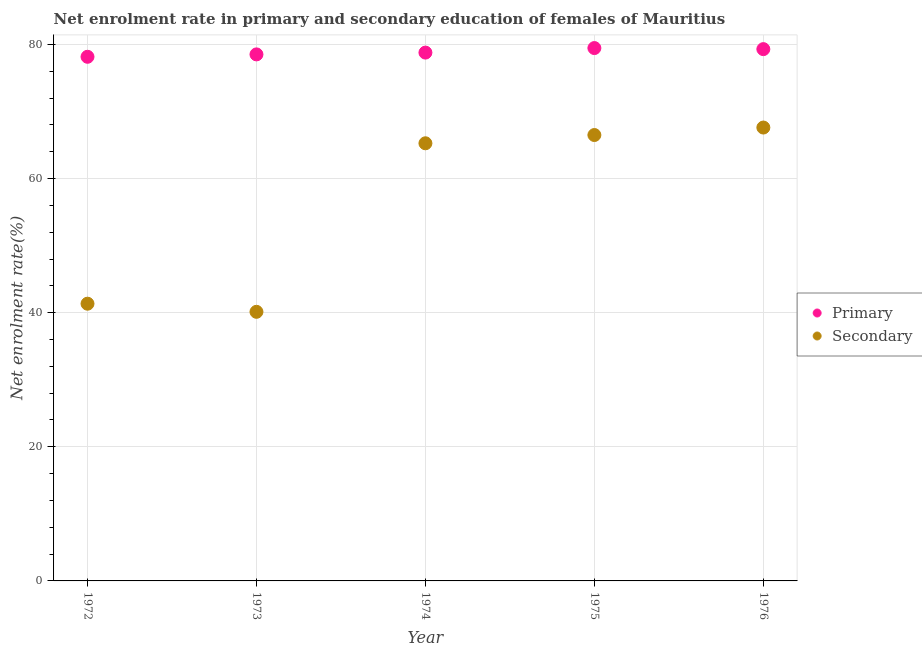How many different coloured dotlines are there?
Your response must be concise. 2. Is the number of dotlines equal to the number of legend labels?
Your answer should be very brief. Yes. What is the enrollment rate in primary education in 1974?
Your answer should be very brief. 78.79. Across all years, what is the maximum enrollment rate in secondary education?
Provide a short and direct response. 67.61. Across all years, what is the minimum enrollment rate in primary education?
Give a very brief answer. 78.16. In which year was the enrollment rate in primary education maximum?
Keep it short and to the point. 1975. What is the total enrollment rate in primary education in the graph?
Offer a very short reply. 394.23. What is the difference between the enrollment rate in primary education in 1972 and that in 1975?
Provide a short and direct response. -1.3. What is the difference between the enrollment rate in secondary education in 1974 and the enrollment rate in primary education in 1976?
Make the answer very short. -14.04. What is the average enrollment rate in primary education per year?
Ensure brevity in your answer.  78.85. In the year 1973, what is the difference between the enrollment rate in secondary education and enrollment rate in primary education?
Make the answer very short. -38.39. What is the ratio of the enrollment rate in primary education in 1972 to that in 1976?
Provide a short and direct response. 0.99. Is the enrollment rate in secondary education in 1973 less than that in 1976?
Provide a succinct answer. Yes. What is the difference between the highest and the second highest enrollment rate in primary education?
Your response must be concise. 0.16. What is the difference between the highest and the lowest enrollment rate in secondary education?
Offer a terse response. 27.48. In how many years, is the enrollment rate in primary education greater than the average enrollment rate in primary education taken over all years?
Your answer should be very brief. 2. How many dotlines are there?
Keep it short and to the point. 2. Does the graph contain any zero values?
Your answer should be very brief. No. Where does the legend appear in the graph?
Provide a succinct answer. Center right. How many legend labels are there?
Provide a succinct answer. 2. How are the legend labels stacked?
Your answer should be very brief. Vertical. What is the title of the graph?
Ensure brevity in your answer.  Net enrolment rate in primary and secondary education of females of Mauritius. Does "Non-resident workers" appear as one of the legend labels in the graph?
Provide a short and direct response. No. What is the label or title of the X-axis?
Ensure brevity in your answer.  Year. What is the label or title of the Y-axis?
Ensure brevity in your answer.  Net enrolment rate(%). What is the Net enrolment rate(%) of Primary in 1972?
Provide a short and direct response. 78.16. What is the Net enrolment rate(%) of Secondary in 1972?
Offer a terse response. 41.34. What is the Net enrolment rate(%) in Primary in 1973?
Your answer should be compact. 78.52. What is the Net enrolment rate(%) of Secondary in 1973?
Keep it short and to the point. 40.13. What is the Net enrolment rate(%) of Primary in 1974?
Ensure brevity in your answer.  78.79. What is the Net enrolment rate(%) in Secondary in 1974?
Your response must be concise. 65.26. What is the Net enrolment rate(%) of Primary in 1975?
Ensure brevity in your answer.  79.46. What is the Net enrolment rate(%) of Secondary in 1975?
Give a very brief answer. 66.49. What is the Net enrolment rate(%) of Primary in 1976?
Your response must be concise. 79.3. What is the Net enrolment rate(%) of Secondary in 1976?
Your response must be concise. 67.61. Across all years, what is the maximum Net enrolment rate(%) of Primary?
Provide a succinct answer. 79.46. Across all years, what is the maximum Net enrolment rate(%) of Secondary?
Keep it short and to the point. 67.61. Across all years, what is the minimum Net enrolment rate(%) of Primary?
Make the answer very short. 78.16. Across all years, what is the minimum Net enrolment rate(%) in Secondary?
Give a very brief answer. 40.13. What is the total Net enrolment rate(%) of Primary in the graph?
Offer a very short reply. 394.23. What is the total Net enrolment rate(%) in Secondary in the graph?
Your answer should be very brief. 280.83. What is the difference between the Net enrolment rate(%) of Primary in 1972 and that in 1973?
Keep it short and to the point. -0.36. What is the difference between the Net enrolment rate(%) of Secondary in 1972 and that in 1973?
Offer a terse response. 1.21. What is the difference between the Net enrolment rate(%) in Primary in 1972 and that in 1974?
Your response must be concise. -0.62. What is the difference between the Net enrolment rate(%) in Secondary in 1972 and that in 1974?
Ensure brevity in your answer.  -23.92. What is the difference between the Net enrolment rate(%) of Primary in 1972 and that in 1975?
Offer a terse response. -1.3. What is the difference between the Net enrolment rate(%) of Secondary in 1972 and that in 1975?
Offer a terse response. -25.15. What is the difference between the Net enrolment rate(%) of Primary in 1972 and that in 1976?
Your answer should be compact. -1.14. What is the difference between the Net enrolment rate(%) of Secondary in 1972 and that in 1976?
Your response must be concise. -26.27. What is the difference between the Net enrolment rate(%) of Primary in 1973 and that in 1974?
Give a very brief answer. -0.27. What is the difference between the Net enrolment rate(%) of Secondary in 1973 and that in 1974?
Offer a terse response. -25.13. What is the difference between the Net enrolment rate(%) of Primary in 1973 and that in 1975?
Your answer should be very brief. -0.94. What is the difference between the Net enrolment rate(%) of Secondary in 1973 and that in 1975?
Keep it short and to the point. -26.36. What is the difference between the Net enrolment rate(%) of Primary in 1973 and that in 1976?
Give a very brief answer. -0.78. What is the difference between the Net enrolment rate(%) of Secondary in 1973 and that in 1976?
Your answer should be very brief. -27.48. What is the difference between the Net enrolment rate(%) of Primary in 1974 and that in 1975?
Offer a terse response. -0.68. What is the difference between the Net enrolment rate(%) in Secondary in 1974 and that in 1975?
Ensure brevity in your answer.  -1.23. What is the difference between the Net enrolment rate(%) of Primary in 1974 and that in 1976?
Offer a terse response. -0.52. What is the difference between the Net enrolment rate(%) in Secondary in 1974 and that in 1976?
Provide a short and direct response. -2.35. What is the difference between the Net enrolment rate(%) in Primary in 1975 and that in 1976?
Ensure brevity in your answer.  0.16. What is the difference between the Net enrolment rate(%) in Secondary in 1975 and that in 1976?
Provide a succinct answer. -1.12. What is the difference between the Net enrolment rate(%) in Primary in 1972 and the Net enrolment rate(%) in Secondary in 1973?
Keep it short and to the point. 38.03. What is the difference between the Net enrolment rate(%) of Primary in 1972 and the Net enrolment rate(%) of Secondary in 1974?
Make the answer very short. 12.9. What is the difference between the Net enrolment rate(%) of Primary in 1972 and the Net enrolment rate(%) of Secondary in 1975?
Your answer should be very brief. 11.67. What is the difference between the Net enrolment rate(%) in Primary in 1972 and the Net enrolment rate(%) in Secondary in 1976?
Your response must be concise. 10.55. What is the difference between the Net enrolment rate(%) in Primary in 1973 and the Net enrolment rate(%) in Secondary in 1974?
Your answer should be compact. 13.26. What is the difference between the Net enrolment rate(%) of Primary in 1973 and the Net enrolment rate(%) of Secondary in 1975?
Ensure brevity in your answer.  12.02. What is the difference between the Net enrolment rate(%) of Primary in 1973 and the Net enrolment rate(%) of Secondary in 1976?
Your answer should be very brief. 10.91. What is the difference between the Net enrolment rate(%) of Primary in 1974 and the Net enrolment rate(%) of Secondary in 1975?
Ensure brevity in your answer.  12.29. What is the difference between the Net enrolment rate(%) of Primary in 1974 and the Net enrolment rate(%) of Secondary in 1976?
Offer a terse response. 11.18. What is the difference between the Net enrolment rate(%) of Primary in 1975 and the Net enrolment rate(%) of Secondary in 1976?
Make the answer very short. 11.85. What is the average Net enrolment rate(%) in Primary per year?
Offer a very short reply. 78.85. What is the average Net enrolment rate(%) of Secondary per year?
Ensure brevity in your answer.  56.17. In the year 1972, what is the difference between the Net enrolment rate(%) in Primary and Net enrolment rate(%) in Secondary?
Your answer should be compact. 36.82. In the year 1973, what is the difference between the Net enrolment rate(%) of Primary and Net enrolment rate(%) of Secondary?
Keep it short and to the point. 38.39. In the year 1974, what is the difference between the Net enrolment rate(%) of Primary and Net enrolment rate(%) of Secondary?
Keep it short and to the point. 13.52. In the year 1975, what is the difference between the Net enrolment rate(%) of Primary and Net enrolment rate(%) of Secondary?
Your answer should be very brief. 12.97. In the year 1976, what is the difference between the Net enrolment rate(%) in Primary and Net enrolment rate(%) in Secondary?
Make the answer very short. 11.69. What is the ratio of the Net enrolment rate(%) of Primary in 1972 to that in 1973?
Your response must be concise. 1. What is the ratio of the Net enrolment rate(%) in Secondary in 1972 to that in 1973?
Offer a terse response. 1.03. What is the ratio of the Net enrolment rate(%) of Primary in 1972 to that in 1974?
Provide a succinct answer. 0.99. What is the ratio of the Net enrolment rate(%) in Secondary in 1972 to that in 1974?
Give a very brief answer. 0.63. What is the ratio of the Net enrolment rate(%) in Primary in 1972 to that in 1975?
Give a very brief answer. 0.98. What is the ratio of the Net enrolment rate(%) of Secondary in 1972 to that in 1975?
Keep it short and to the point. 0.62. What is the ratio of the Net enrolment rate(%) in Primary in 1972 to that in 1976?
Provide a short and direct response. 0.99. What is the ratio of the Net enrolment rate(%) in Secondary in 1972 to that in 1976?
Make the answer very short. 0.61. What is the ratio of the Net enrolment rate(%) of Secondary in 1973 to that in 1974?
Make the answer very short. 0.61. What is the ratio of the Net enrolment rate(%) in Primary in 1973 to that in 1975?
Offer a very short reply. 0.99. What is the ratio of the Net enrolment rate(%) in Secondary in 1973 to that in 1975?
Your answer should be compact. 0.6. What is the ratio of the Net enrolment rate(%) of Primary in 1973 to that in 1976?
Provide a short and direct response. 0.99. What is the ratio of the Net enrolment rate(%) of Secondary in 1973 to that in 1976?
Your answer should be very brief. 0.59. What is the ratio of the Net enrolment rate(%) in Primary in 1974 to that in 1975?
Offer a very short reply. 0.99. What is the ratio of the Net enrolment rate(%) in Secondary in 1974 to that in 1975?
Provide a succinct answer. 0.98. What is the ratio of the Net enrolment rate(%) in Primary in 1974 to that in 1976?
Keep it short and to the point. 0.99. What is the ratio of the Net enrolment rate(%) in Secondary in 1974 to that in 1976?
Offer a very short reply. 0.97. What is the ratio of the Net enrolment rate(%) in Secondary in 1975 to that in 1976?
Your answer should be compact. 0.98. What is the difference between the highest and the second highest Net enrolment rate(%) of Primary?
Give a very brief answer. 0.16. What is the difference between the highest and the second highest Net enrolment rate(%) of Secondary?
Make the answer very short. 1.12. What is the difference between the highest and the lowest Net enrolment rate(%) of Primary?
Ensure brevity in your answer.  1.3. What is the difference between the highest and the lowest Net enrolment rate(%) of Secondary?
Provide a short and direct response. 27.48. 